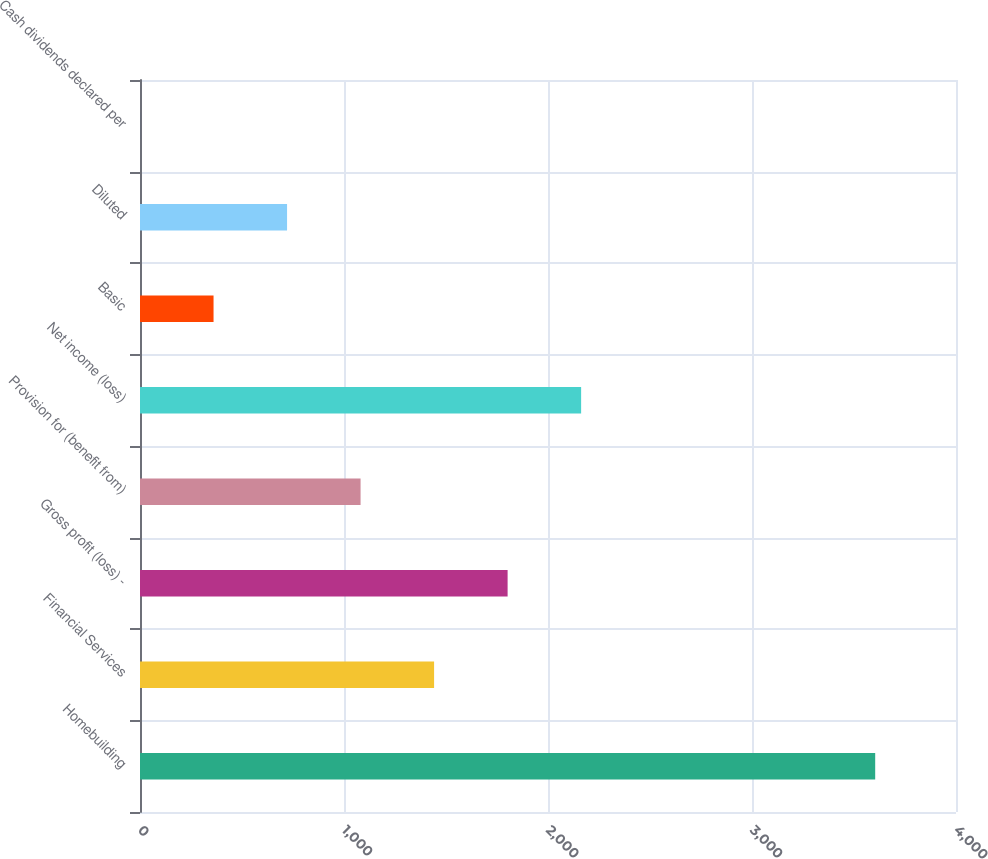<chart> <loc_0><loc_0><loc_500><loc_500><bar_chart><fcel>Homebuilding<fcel>Financial Services<fcel>Gross profit (loss) -<fcel>Provision for (benefit from)<fcel>Net income (loss)<fcel>Basic<fcel>Diluted<fcel>Cash dividends declared per<nl><fcel>3603.9<fcel>1441.63<fcel>1802.01<fcel>1081.26<fcel>2162.39<fcel>360.52<fcel>720.89<fcel>0.15<nl></chart> 